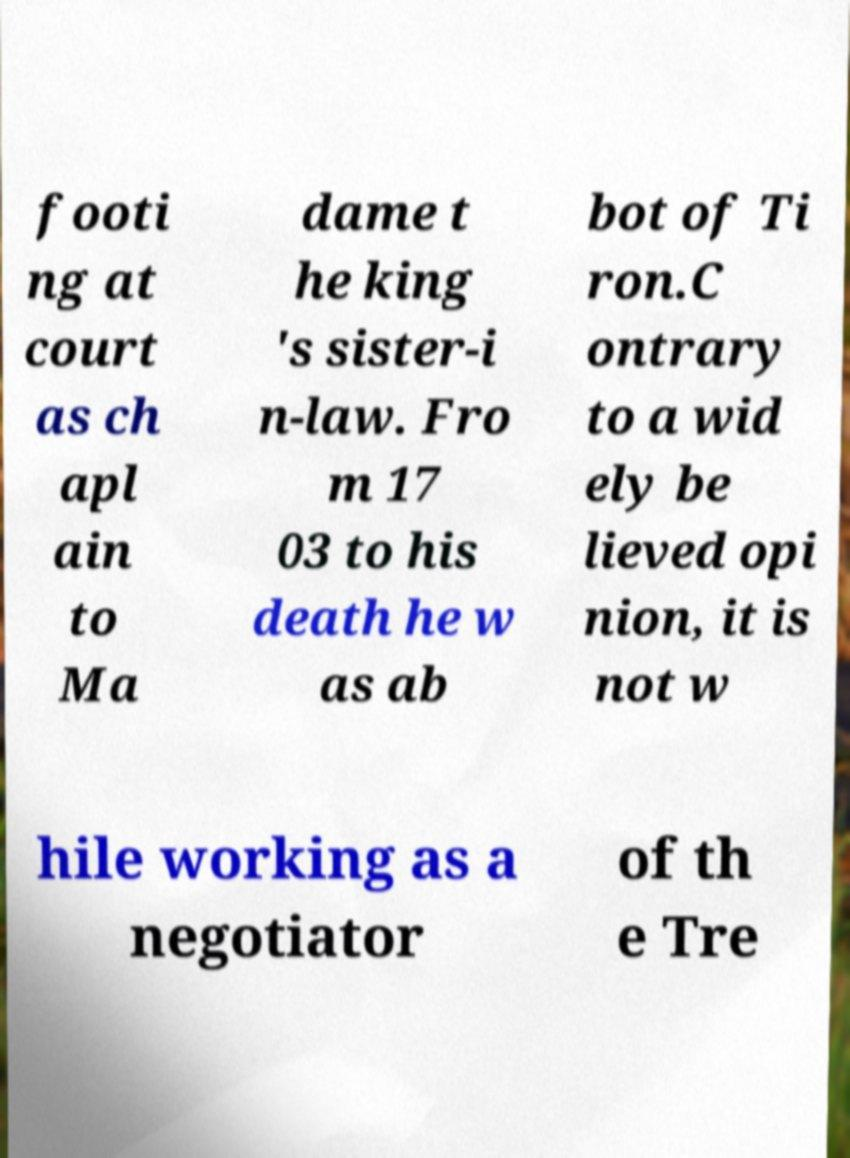Please identify and transcribe the text found in this image. footi ng at court as ch apl ain to Ma dame t he king 's sister-i n-law. Fro m 17 03 to his death he w as ab bot of Ti ron.C ontrary to a wid ely be lieved opi nion, it is not w hile working as a negotiator of th e Tre 